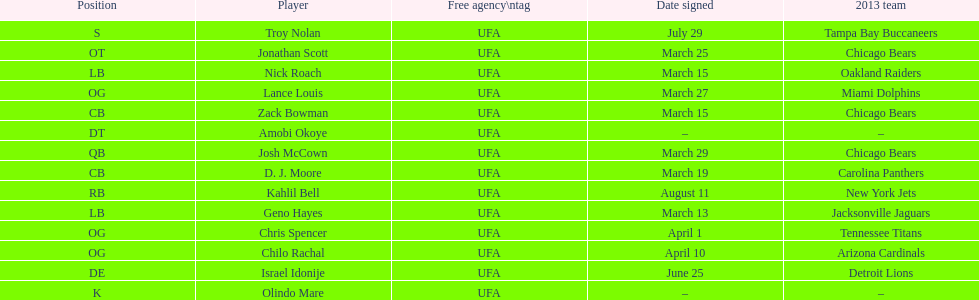The only player to sign in july? Troy Nolan. 